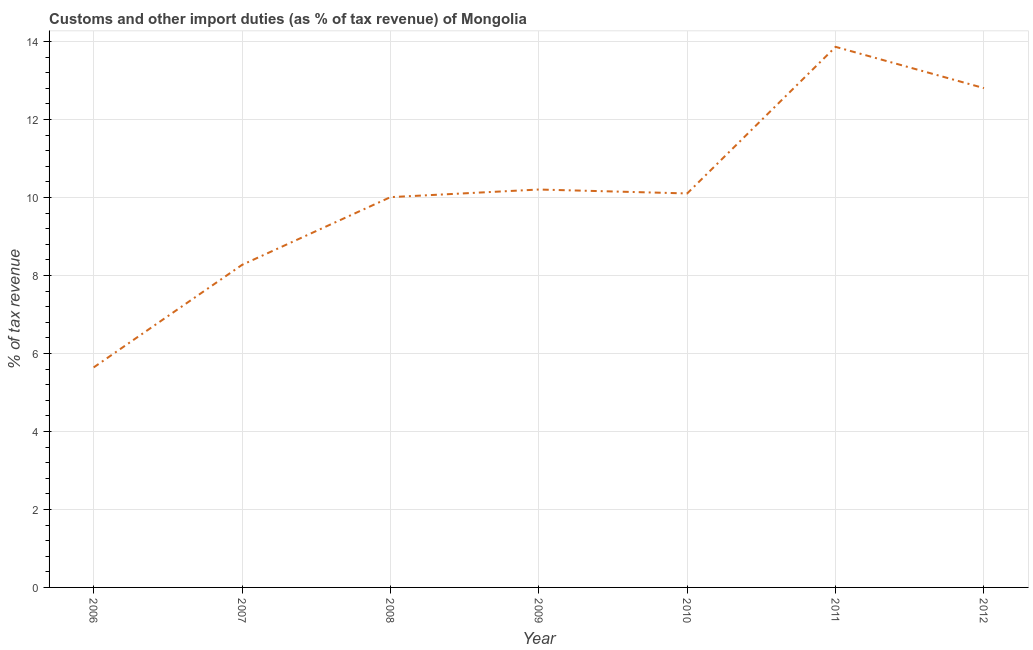What is the customs and other import duties in 2007?
Your response must be concise. 8.27. Across all years, what is the maximum customs and other import duties?
Your answer should be very brief. 13.86. Across all years, what is the minimum customs and other import duties?
Provide a short and direct response. 5.64. In which year was the customs and other import duties maximum?
Provide a short and direct response. 2011. What is the sum of the customs and other import duties?
Your response must be concise. 70.89. What is the difference between the customs and other import duties in 2008 and 2011?
Keep it short and to the point. -3.85. What is the average customs and other import duties per year?
Give a very brief answer. 10.13. What is the median customs and other import duties?
Keep it short and to the point. 10.1. In how many years, is the customs and other import duties greater than 11.6 %?
Offer a terse response. 2. What is the ratio of the customs and other import duties in 2007 to that in 2010?
Your answer should be very brief. 0.82. Is the customs and other import duties in 2006 less than that in 2011?
Your answer should be very brief. Yes. Is the difference between the customs and other import duties in 2010 and 2011 greater than the difference between any two years?
Your answer should be very brief. No. What is the difference between the highest and the second highest customs and other import duties?
Ensure brevity in your answer.  1.06. What is the difference between the highest and the lowest customs and other import duties?
Provide a succinct answer. 8.22. In how many years, is the customs and other import duties greater than the average customs and other import duties taken over all years?
Offer a terse response. 3. How many lines are there?
Make the answer very short. 1. What is the difference between two consecutive major ticks on the Y-axis?
Offer a very short reply. 2. What is the title of the graph?
Provide a short and direct response. Customs and other import duties (as % of tax revenue) of Mongolia. What is the label or title of the X-axis?
Keep it short and to the point. Year. What is the label or title of the Y-axis?
Your answer should be very brief. % of tax revenue. What is the % of tax revenue of 2006?
Provide a succinct answer. 5.64. What is the % of tax revenue of 2007?
Provide a succinct answer. 8.27. What is the % of tax revenue of 2008?
Provide a succinct answer. 10.01. What is the % of tax revenue of 2009?
Offer a terse response. 10.2. What is the % of tax revenue in 2010?
Keep it short and to the point. 10.1. What is the % of tax revenue in 2011?
Give a very brief answer. 13.86. What is the % of tax revenue in 2012?
Your response must be concise. 12.8. What is the difference between the % of tax revenue in 2006 and 2007?
Your response must be concise. -2.63. What is the difference between the % of tax revenue in 2006 and 2008?
Your answer should be very brief. -4.37. What is the difference between the % of tax revenue in 2006 and 2009?
Offer a terse response. -4.56. What is the difference between the % of tax revenue in 2006 and 2010?
Make the answer very short. -4.46. What is the difference between the % of tax revenue in 2006 and 2011?
Your answer should be compact. -8.22. What is the difference between the % of tax revenue in 2006 and 2012?
Provide a succinct answer. -7.16. What is the difference between the % of tax revenue in 2007 and 2008?
Offer a very short reply. -1.74. What is the difference between the % of tax revenue in 2007 and 2009?
Give a very brief answer. -1.93. What is the difference between the % of tax revenue in 2007 and 2010?
Provide a short and direct response. -1.83. What is the difference between the % of tax revenue in 2007 and 2011?
Offer a very short reply. -5.59. What is the difference between the % of tax revenue in 2007 and 2012?
Your answer should be compact. -4.53. What is the difference between the % of tax revenue in 2008 and 2009?
Keep it short and to the point. -0.2. What is the difference between the % of tax revenue in 2008 and 2010?
Give a very brief answer. -0.09. What is the difference between the % of tax revenue in 2008 and 2011?
Provide a short and direct response. -3.85. What is the difference between the % of tax revenue in 2008 and 2012?
Your answer should be compact. -2.8. What is the difference between the % of tax revenue in 2009 and 2010?
Provide a short and direct response. 0.1. What is the difference between the % of tax revenue in 2009 and 2011?
Give a very brief answer. -3.66. What is the difference between the % of tax revenue in 2009 and 2012?
Your answer should be compact. -2.6. What is the difference between the % of tax revenue in 2010 and 2011?
Ensure brevity in your answer.  -3.76. What is the difference between the % of tax revenue in 2010 and 2012?
Provide a succinct answer. -2.7. What is the difference between the % of tax revenue in 2011 and 2012?
Ensure brevity in your answer.  1.06. What is the ratio of the % of tax revenue in 2006 to that in 2007?
Your answer should be very brief. 0.68. What is the ratio of the % of tax revenue in 2006 to that in 2008?
Your response must be concise. 0.56. What is the ratio of the % of tax revenue in 2006 to that in 2009?
Provide a short and direct response. 0.55. What is the ratio of the % of tax revenue in 2006 to that in 2010?
Offer a very short reply. 0.56. What is the ratio of the % of tax revenue in 2006 to that in 2011?
Your response must be concise. 0.41. What is the ratio of the % of tax revenue in 2006 to that in 2012?
Your response must be concise. 0.44. What is the ratio of the % of tax revenue in 2007 to that in 2008?
Your answer should be compact. 0.83. What is the ratio of the % of tax revenue in 2007 to that in 2009?
Provide a succinct answer. 0.81. What is the ratio of the % of tax revenue in 2007 to that in 2010?
Ensure brevity in your answer.  0.82. What is the ratio of the % of tax revenue in 2007 to that in 2011?
Provide a short and direct response. 0.6. What is the ratio of the % of tax revenue in 2007 to that in 2012?
Your response must be concise. 0.65. What is the ratio of the % of tax revenue in 2008 to that in 2009?
Ensure brevity in your answer.  0.98. What is the ratio of the % of tax revenue in 2008 to that in 2010?
Your answer should be compact. 0.99. What is the ratio of the % of tax revenue in 2008 to that in 2011?
Offer a terse response. 0.72. What is the ratio of the % of tax revenue in 2008 to that in 2012?
Ensure brevity in your answer.  0.78. What is the ratio of the % of tax revenue in 2009 to that in 2011?
Provide a short and direct response. 0.74. What is the ratio of the % of tax revenue in 2009 to that in 2012?
Keep it short and to the point. 0.8. What is the ratio of the % of tax revenue in 2010 to that in 2011?
Give a very brief answer. 0.73. What is the ratio of the % of tax revenue in 2010 to that in 2012?
Your answer should be very brief. 0.79. What is the ratio of the % of tax revenue in 2011 to that in 2012?
Make the answer very short. 1.08. 